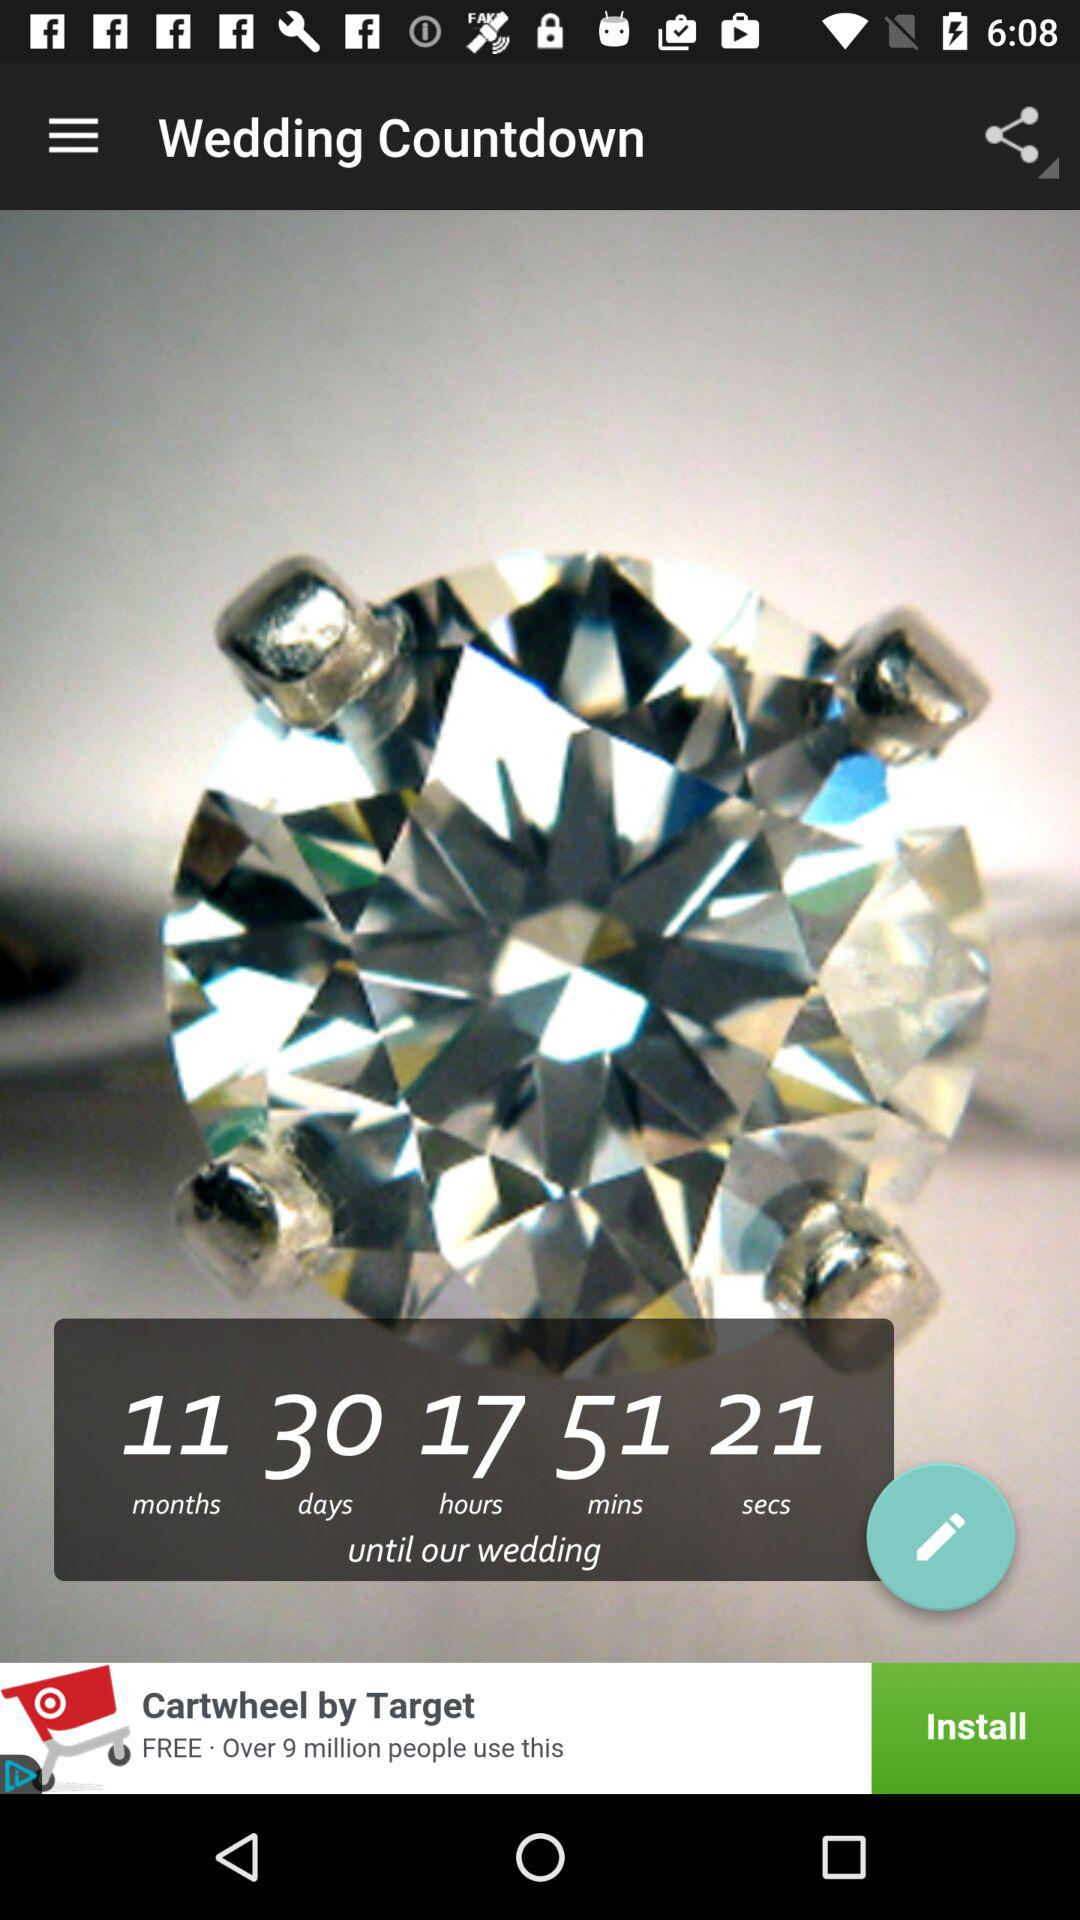What is the application name? The application name is "Wedding Countdown". 